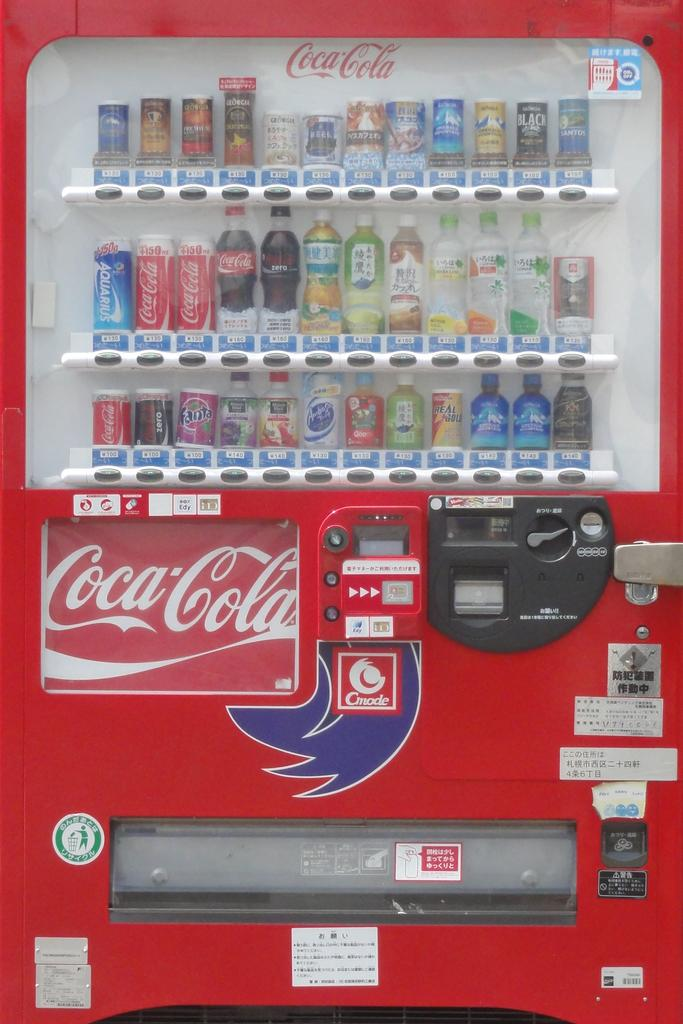<image>
Give a short and clear explanation of the subsequent image. A red coca cola vending machine with many drinks inside. 